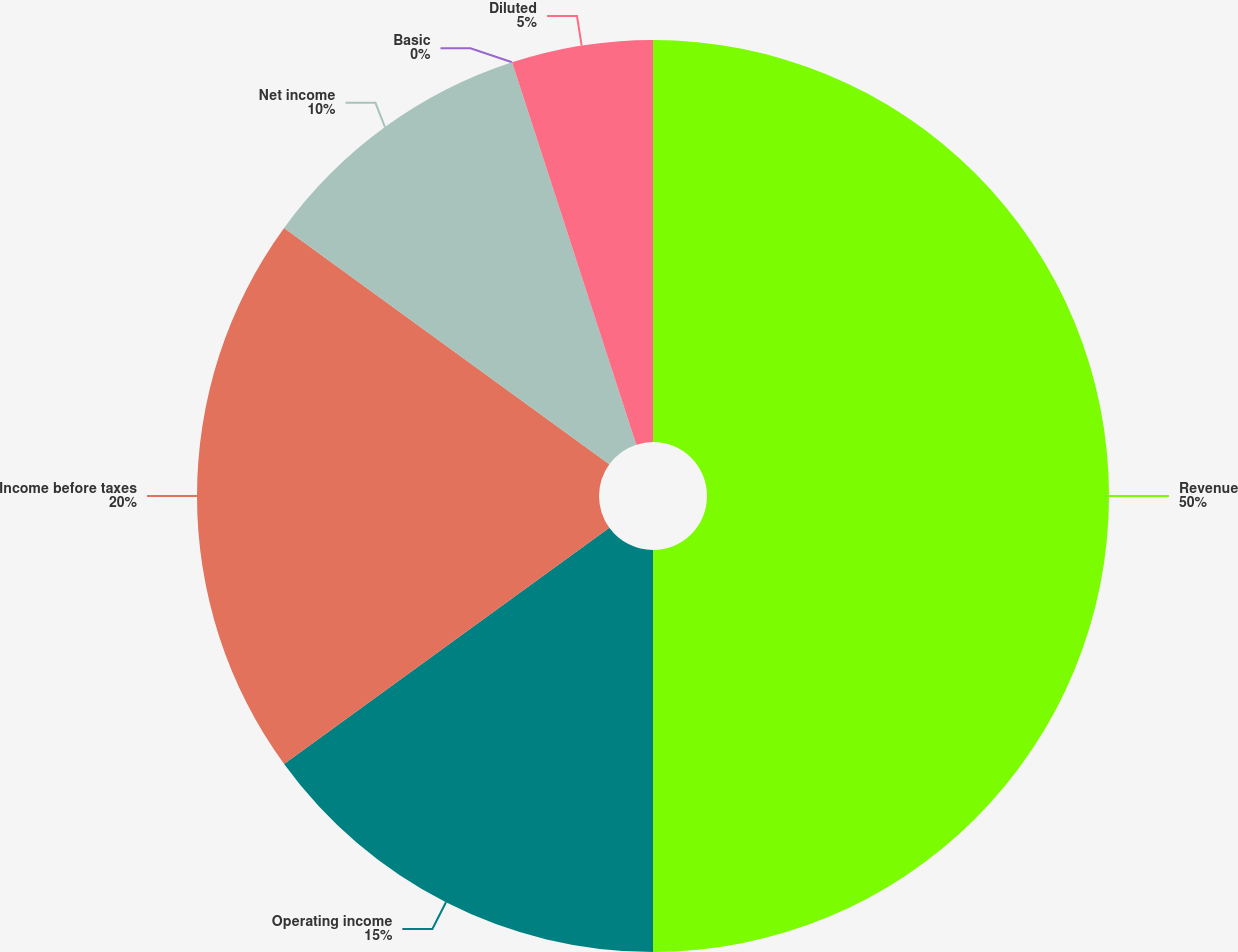Convert chart. <chart><loc_0><loc_0><loc_500><loc_500><pie_chart><fcel>Revenue<fcel>Operating income<fcel>Income before taxes<fcel>Net income<fcel>Basic<fcel>Diluted<nl><fcel>50.0%<fcel>15.0%<fcel>20.0%<fcel>10.0%<fcel>0.0%<fcel>5.0%<nl></chart> 